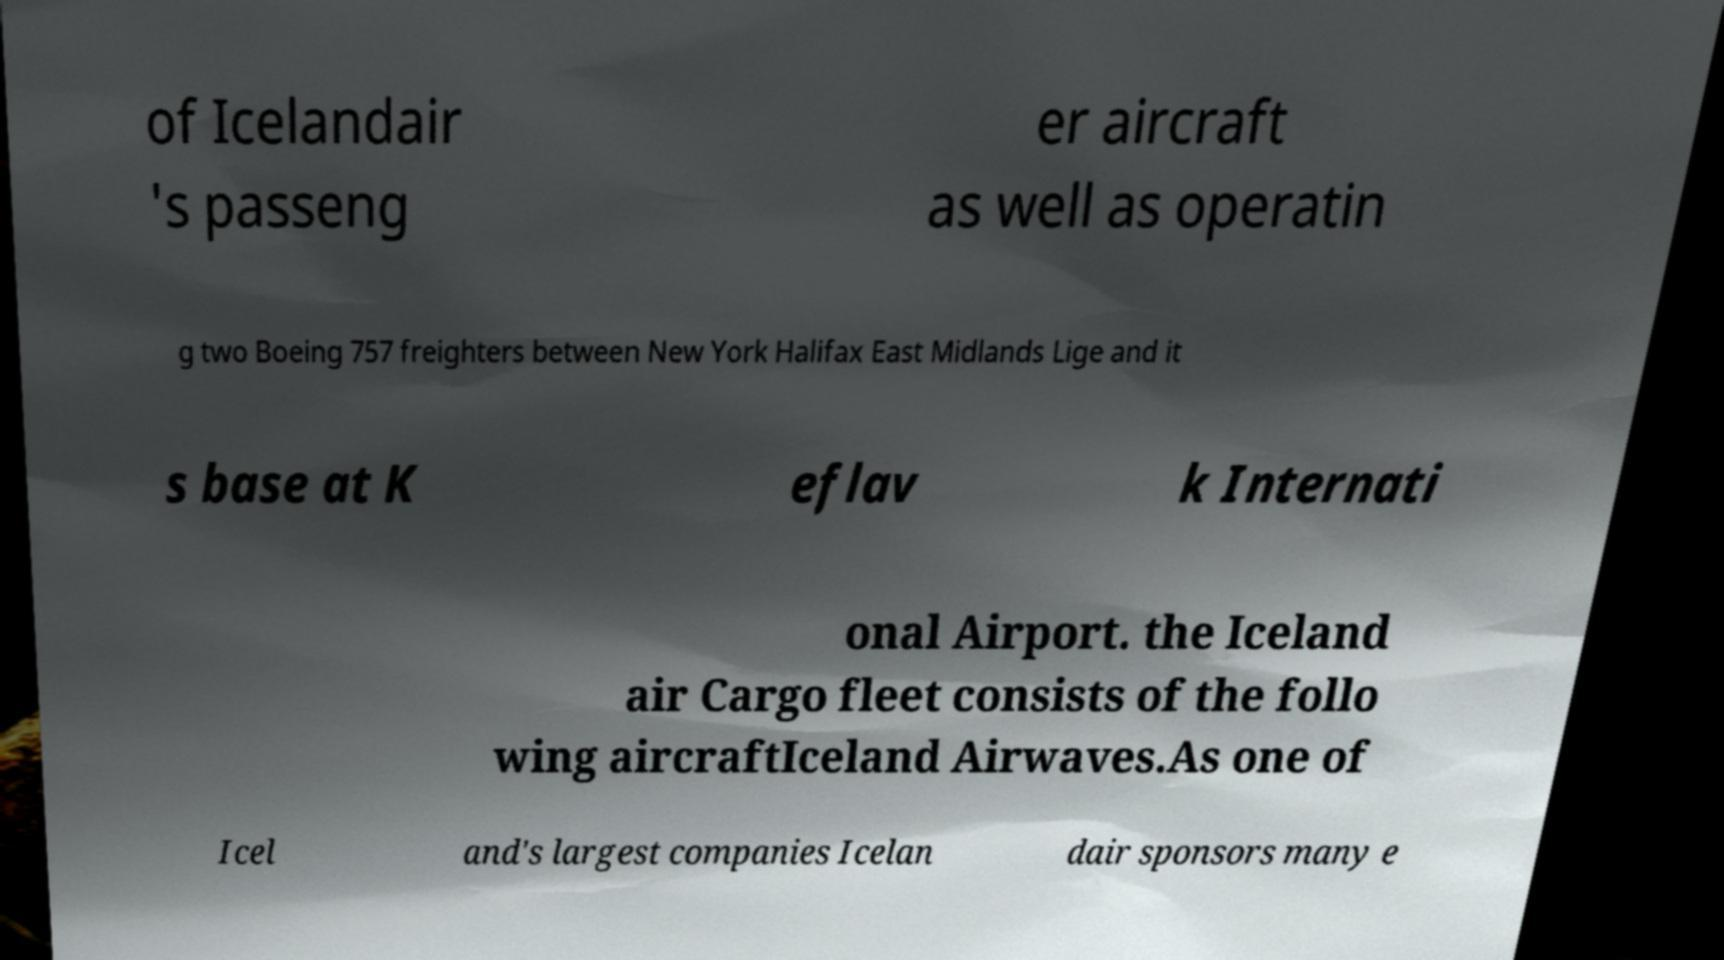There's text embedded in this image that I need extracted. Can you transcribe it verbatim? of Icelandair 's passeng er aircraft as well as operatin g two Boeing 757 freighters between New York Halifax East Midlands Lige and it s base at K eflav k Internati onal Airport. the Iceland air Cargo fleet consists of the follo wing aircraftIceland Airwaves.As one of Icel and's largest companies Icelan dair sponsors many e 